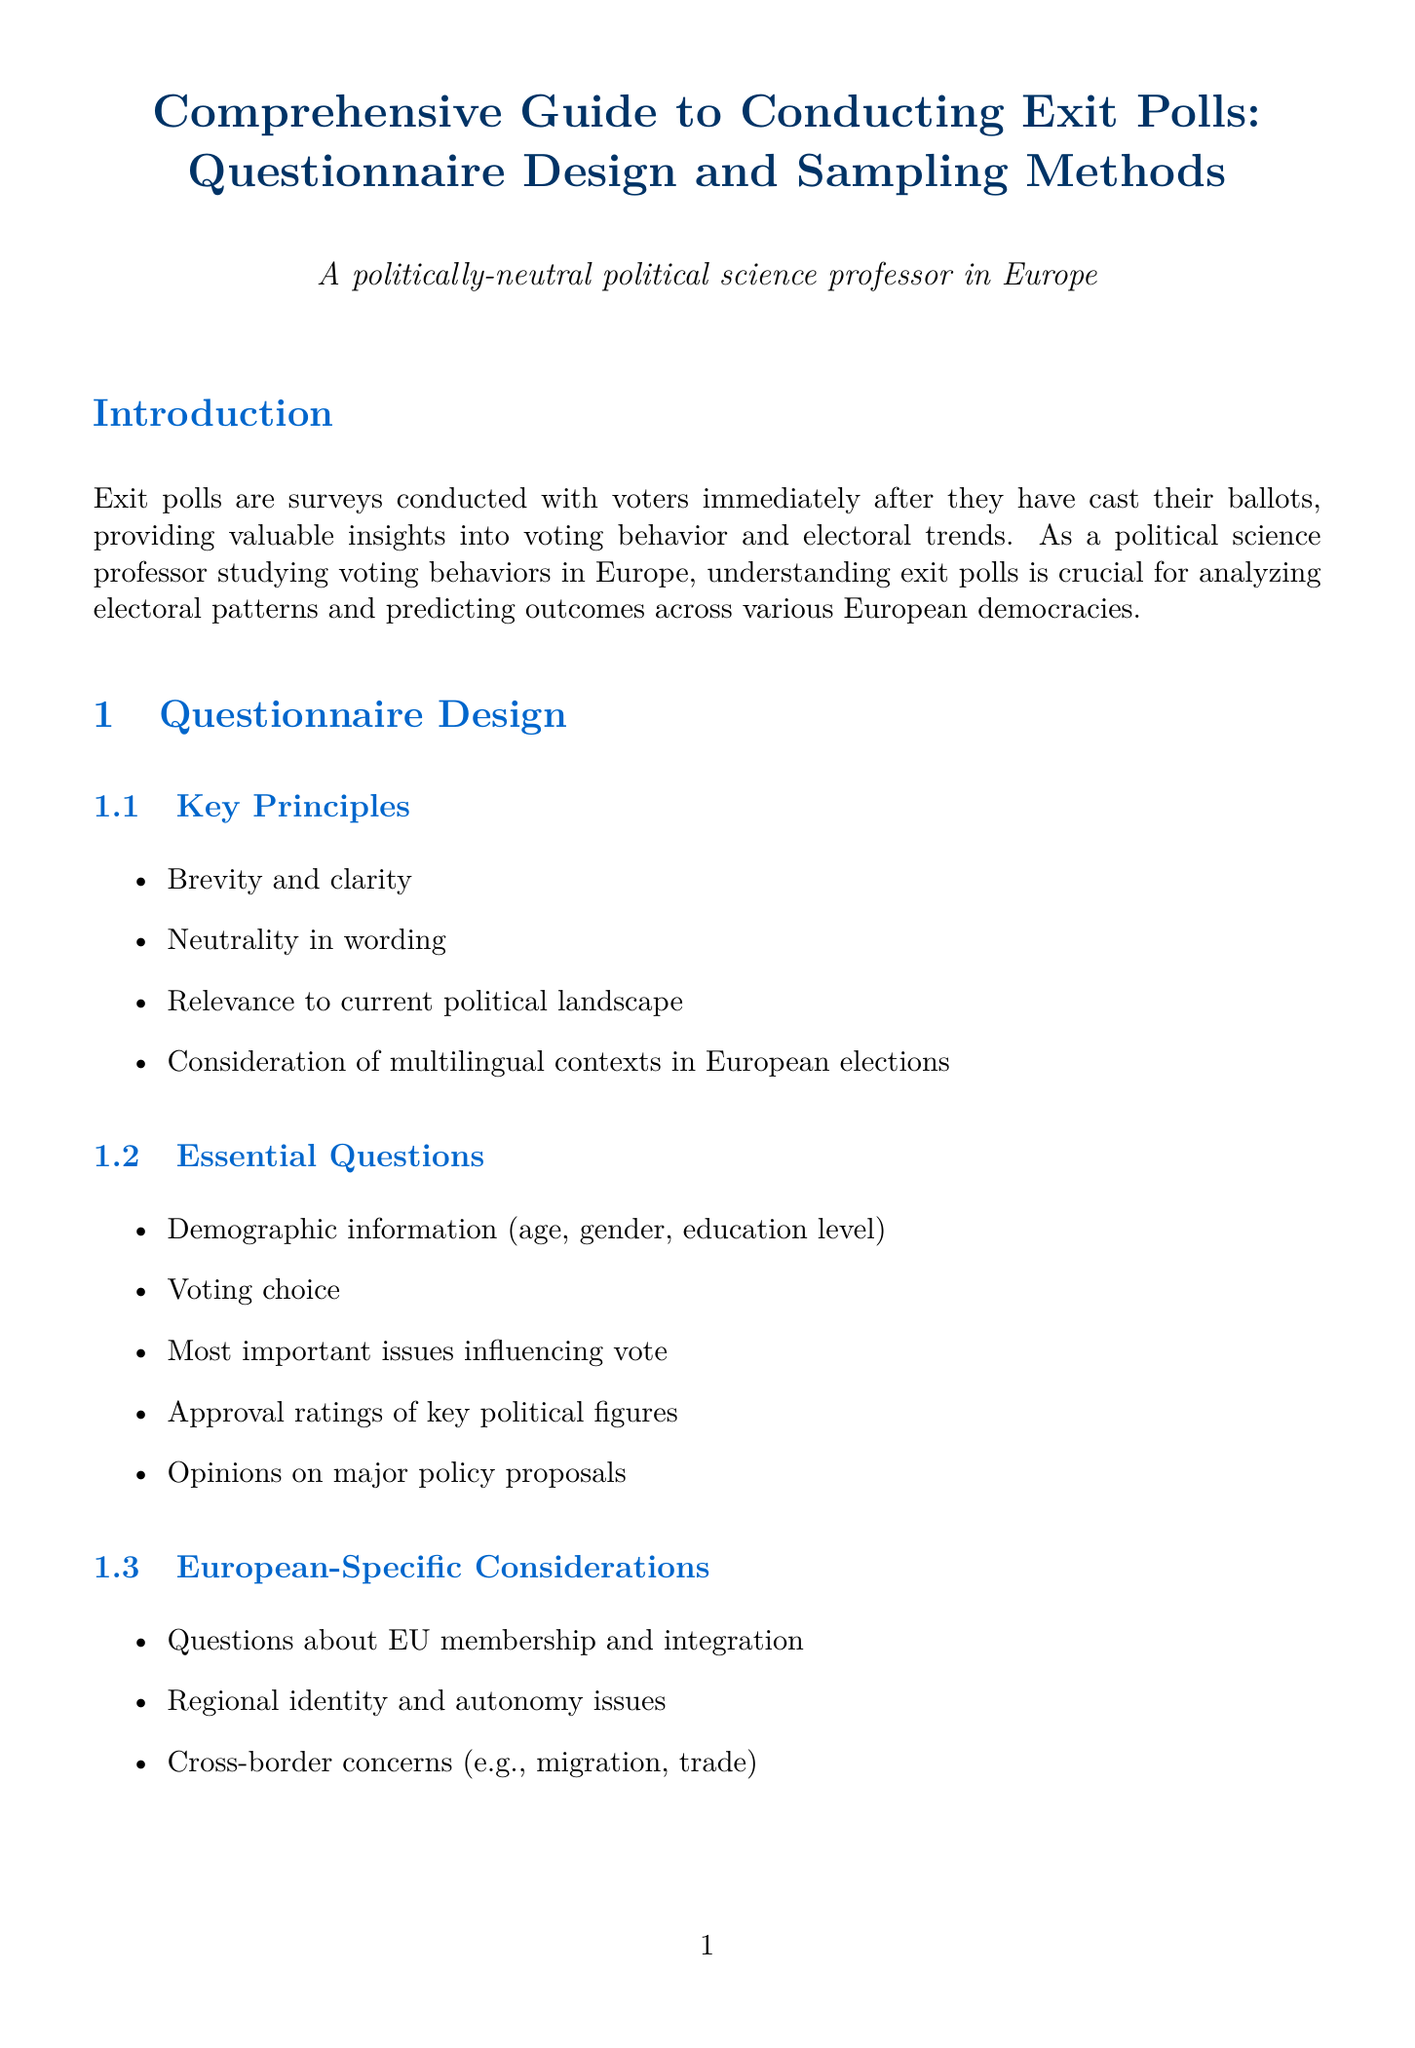what are exit polls? Exit polls are defined as surveys conducted with voters immediately after they have cast their ballots.
Answer: Surveys conducted with voters immediately after they have cast their ballots name one key principle of questionnaire design. Key principles include brevity and clarity, neutrality in wording, relevance to current political landscape, and multilingual contexts.
Answer: Brevity and clarity what is one factor in sample size determination? Factors in sample size determination include desired level of precision, confidence level, expected margin of error, and population size.
Answer: Desired level of precision which statistical software is mentioned for data analysis? The document mentions several statistical software packages including SPSS, R, Stata, and Python.
Answer: SPSS what challenge is mentioned regarding exit polls? The document lists several challenges including potential for sampling bias, reluctance of voters to participate, and rapid changes in political landscapes.
Answer: Potential for sampling bias what ethical principle relates to participation? The ethical principle concerning participation is that it should be voluntary.
Answer: Voluntary participation name a consideration specific to the European context of sampling methods. The European context involves varying electoral systems across countries, multi-party systems, and proportional representation versus first-past-the-post.
Answer: Varying electoral systems across countries what modern data collection method is used? The document discusses the use of tablet-based surveys and QR code-linked online surveys.
Answer: Tablet-based surveys 